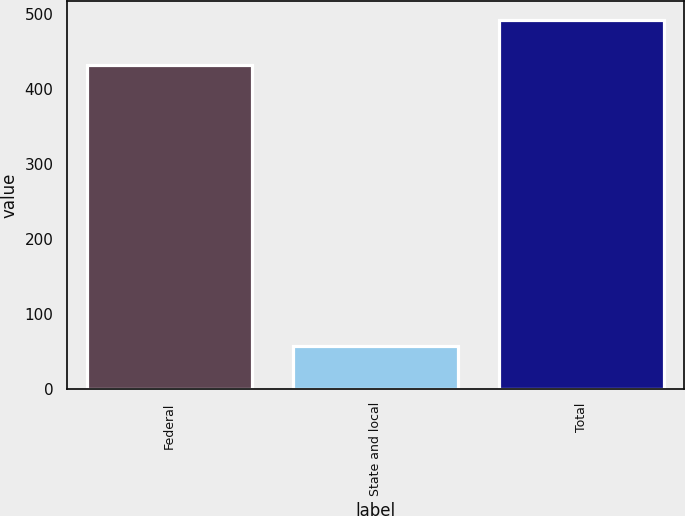<chart> <loc_0><loc_0><loc_500><loc_500><bar_chart><fcel>Federal<fcel>State and local<fcel>Total<nl><fcel>432<fcel>57<fcel>492<nl></chart> 